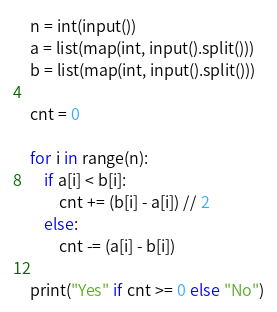<code> <loc_0><loc_0><loc_500><loc_500><_Python_>n = int(input())
a = list(map(int, input().split()))
b = list(map(int, input().split()))

cnt = 0

for i in range(n):
    if a[i] < b[i]:
        cnt += (b[i] - a[i]) // 2
    else:
        cnt -= (a[i] - b[i])

print("Yes" if cnt >= 0 else "No")
</code> 